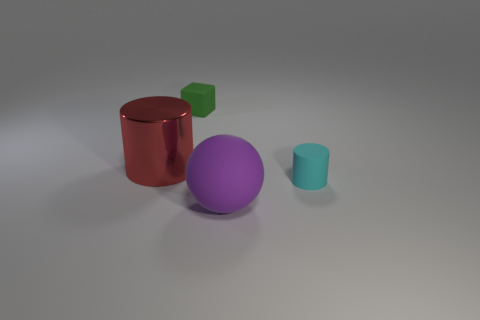Add 2 big purple objects. How many objects exist? 6 Subtract all cubes. How many objects are left? 3 Subtract 1 red cylinders. How many objects are left? 3 Subtract all green blocks. Subtract all small rubber cylinders. How many objects are left? 2 Add 1 tiny cyan rubber things. How many tiny cyan rubber things are left? 2 Add 4 small cyan matte objects. How many small cyan matte objects exist? 5 